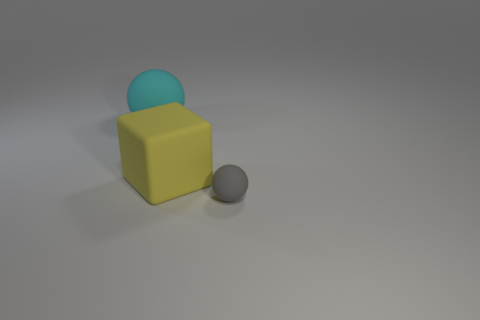Are there any other things that are the same shape as the yellow thing?
Provide a succinct answer. No. Is there any other thing that is the same size as the gray sphere?
Provide a succinct answer. No. How many large blue rubber spheres are there?
Keep it short and to the point. 0. Are there any red spheres that have the same size as the cyan ball?
Keep it short and to the point. No. Is the shape of the large yellow thing the same as the thing that is behind the big rubber block?
Offer a terse response. No. Is there a tiny thing to the right of the large object that is right of the ball behind the small gray matte ball?
Make the answer very short. Yes. The yellow matte cube has what size?
Offer a terse response. Large. How many other things are there of the same color as the small thing?
Keep it short and to the point. 0. Is the shape of the big matte thing that is right of the cyan matte sphere the same as  the gray matte thing?
Give a very brief answer. No. What is the color of the other object that is the same shape as the gray rubber object?
Give a very brief answer. Cyan. 